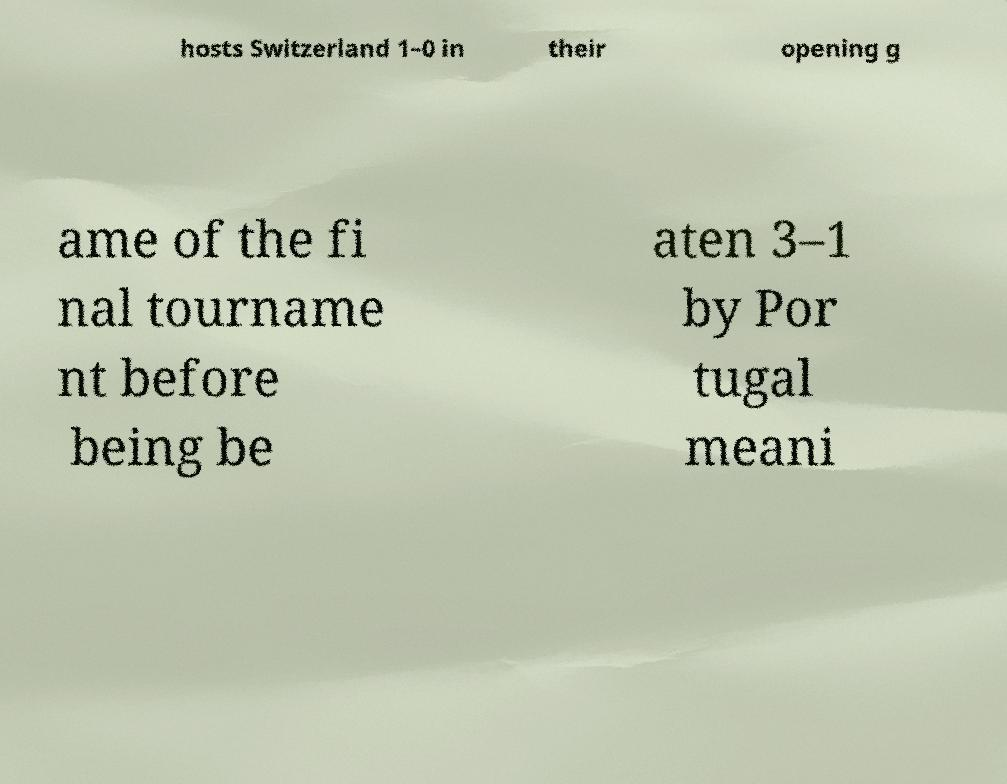I need the written content from this picture converted into text. Can you do that? hosts Switzerland 1–0 in their opening g ame of the fi nal tourname nt before being be aten 3–1 by Por tugal meani 